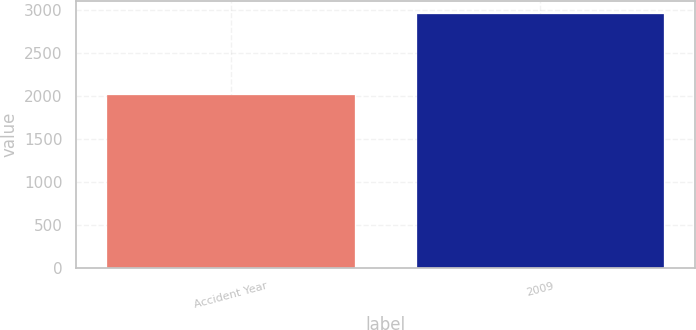<chart> <loc_0><loc_0><loc_500><loc_500><bar_chart><fcel>Accident Year<fcel>2009<nl><fcel>2017<fcel>2957<nl></chart> 